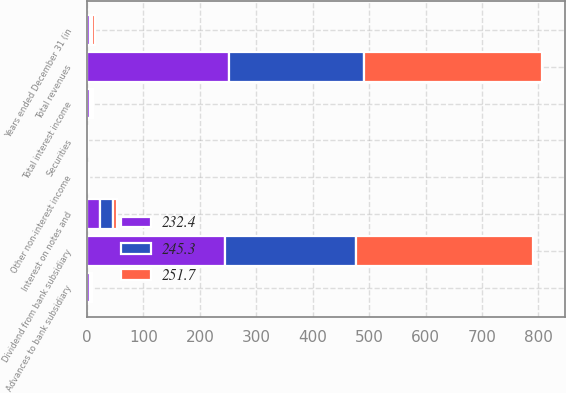<chart> <loc_0><loc_0><loc_500><loc_500><stacked_bar_chart><ecel><fcel>Years ended December 31 (in<fcel>Advances to bank subsidiary<fcel>Securities<fcel>Total interest income<fcel>Dividend from bank subsidiary<fcel>Other non-interest income<fcel>Total revenues<fcel>Interest on notes and<nl><fcel>232.4<fcel>4.4<fcel>4.4<fcel>0.4<fcel>4.8<fcel>244<fcel>1.2<fcel>252.3<fcel>22.4<nl><fcel>245.3<fcel>4.4<fcel>4.1<fcel>0.3<fcel>4.4<fcel>232<fcel>2<fcel>238.4<fcel>23<nl><fcel>251.7<fcel>4.4<fcel>0.9<fcel>0.4<fcel>1.3<fcel>315<fcel>0.2<fcel>316.5<fcel>7.2<nl></chart> 